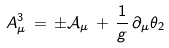<formula> <loc_0><loc_0><loc_500><loc_500>A ^ { 3 } _ { \mu } \, = \, \pm \mathcal { A } _ { \mu } \, + \, \frac { 1 } { g } \, \partial _ { \mu } \theta _ { 2 }</formula> 